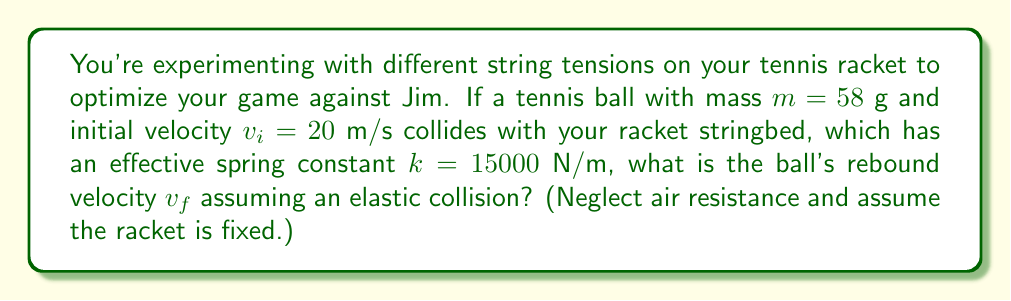What is the answer to this math problem? Let's approach this step-by-step using the principles of elastic collision and simple harmonic motion:

1) In an elastic collision, kinetic energy is conserved. The racket strings act as a spring, converting the ball's kinetic energy into potential energy and then back to kinetic energy.

2) The maximum compression of the strings occurs when all the initial kinetic energy of the ball is converted to potential energy in the strings. Let's call this maximum compression $x$.

3) We can equate the initial kinetic energy to the maximum potential energy in the spring:

   $$\frac{1}{2}mv_i^2 = \frac{1}{2}kx^2$$

4) Solving for $x$:

   $$x = v_i\sqrt{\frac{m}{k}}$$

5) Now, as the ball rebounds, this potential energy is converted back to kinetic energy. The final velocity will be in the opposite direction but with the same magnitude as the initial velocity (in an ideal elastic collision).

6) Therefore, the magnitude of the rebound velocity $v_f$ is equal to $v_i$:

   $$v_f = v_i = 20 \text{ m/s}$$

7) However, the direction is opposite, so we express this as:

   $$v_f = -20 \text{ m/s}$$

The negative sign indicates that the ball is moving in the opposite direction after the collision.
Answer: $-20$ m/s 